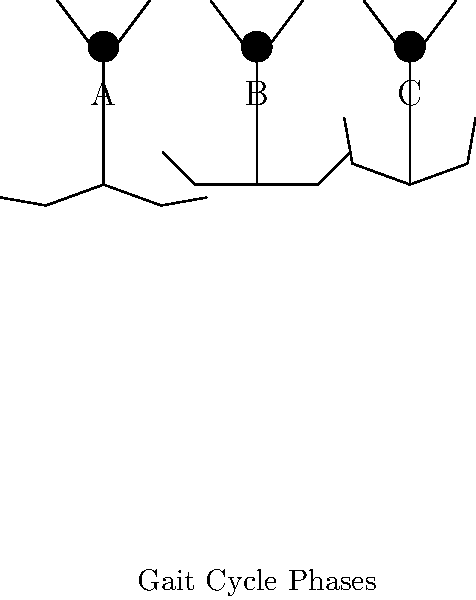Analyze the stick figure illustrations depicting different phases of the gait cycle. Which phase represents the mid-stance, and how does the artistic representation of joint angles in this phase reflect the biomechanical principles of weight distribution and stability during walking? To answer this question, let's analyze each stick figure representation and its corresponding gait cycle phase:

1. Figure A:
   - The leading leg is slightly bent at the knee and hip.
   - The trailing leg is extended behind the body.
   - This represents the initial contact or heel strike phase.

2. Figure B:
   - The body is directly over the supporting leg.
   - The knee is slightly flexed, and the ankle is in a neutral position.
   - The opposite leg is in mid-swing.
   - This represents the mid-stance phase.

3. Figure C:
   - The supporting leg is extended behind the body.
   - The opposite leg is swinging forward, preparing for heel strike.
   - This represents the terminal stance or push-off phase.

The mid-stance phase (Figure B) is crucial for weight distribution and stability:

1. Joint angles:
   - The knee is slightly flexed (approximately 15°).
   - The ankle is in a neutral position.
   - The hip is in slight extension.

2. Biomechanical principles reflected:
   - Weight distribution: The body's center of mass is aligned over the supporting leg, allowing for efficient weight transfer.
   - Stability: The slight knee flexion acts as a shock absorber and provides stability.
   - Energy conservation: The neutral ankle position minimizes energy expenditure.

3. Artistic representation:
   - The vertical alignment of the body over the supporting leg emphasizes the stability aspect.
   - The subtle bend in the knee visually communicates the shock absorption function.
   - The balanced positioning of the arms adds to the overall sense of equilibrium.

The artistic style effectively communicates these biomechanical principles through simple yet precise stick figure representations, allowing the reader to visualize and analyze the key aspects of the gait cycle.
Answer: Figure B represents mid-stance, illustrating stability through vertical alignment and slight knee flexion for weight distribution and shock absorption. 